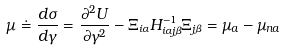Convert formula to latex. <formula><loc_0><loc_0><loc_500><loc_500>\mu \doteq \frac { d \sigma } { d \gamma } = \frac { \partial ^ { 2 } U } { \partial \gamma ^ { 2 } } - \Xi _ { i \alpha } H ^ { - 1 } _ { i \alpha j \beta } \Xi _ { j \beta } = \mu _ { a } - \mu _ { n a }</formula> 